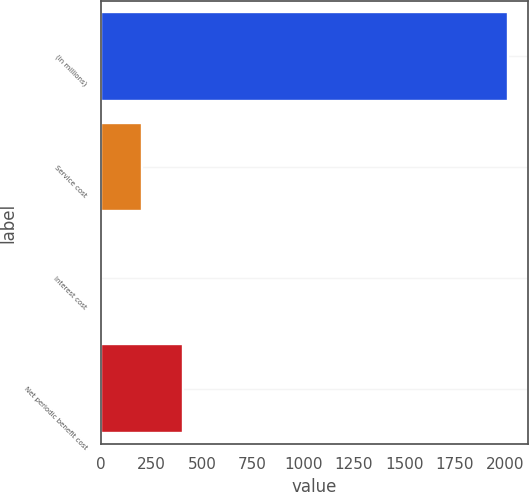Convert chart to OTSL. <chart><loc_0><loc_0><loc_500><loc_500><bar_chart><fcel>(in millions)<fcel>Service cost<fcel>Interest cost<fcel>Net periodic benefit cost<nl><fcel>2013<fcel>203.1<fcel>2<fcel>404.2<nl></chart> 